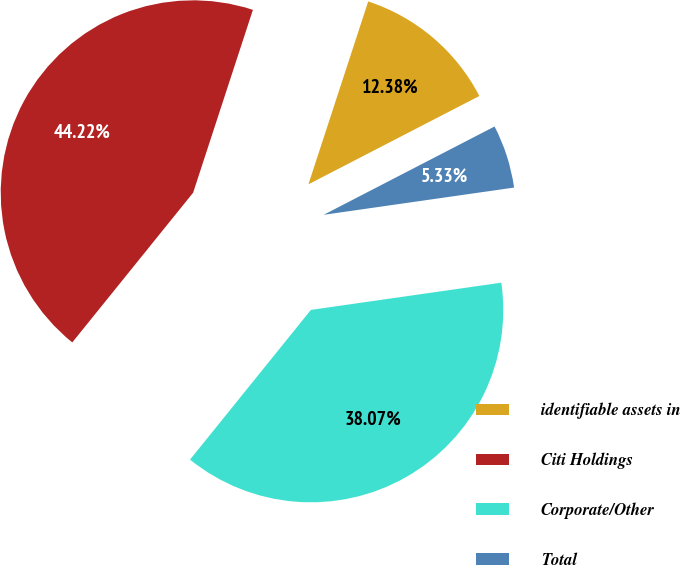Convert chart to OTSL. <chart><loc_0><loc_0><loc_500><loc_500><pie_chart><fcel>identifiable assets in<fcel>Citi Holdings<fcel>Corporate/Other<fcel>Total<nl><fcel>12.38%<fcel>44.22%<fcel>38.07%<fcel>5.33%<nl></chart> 